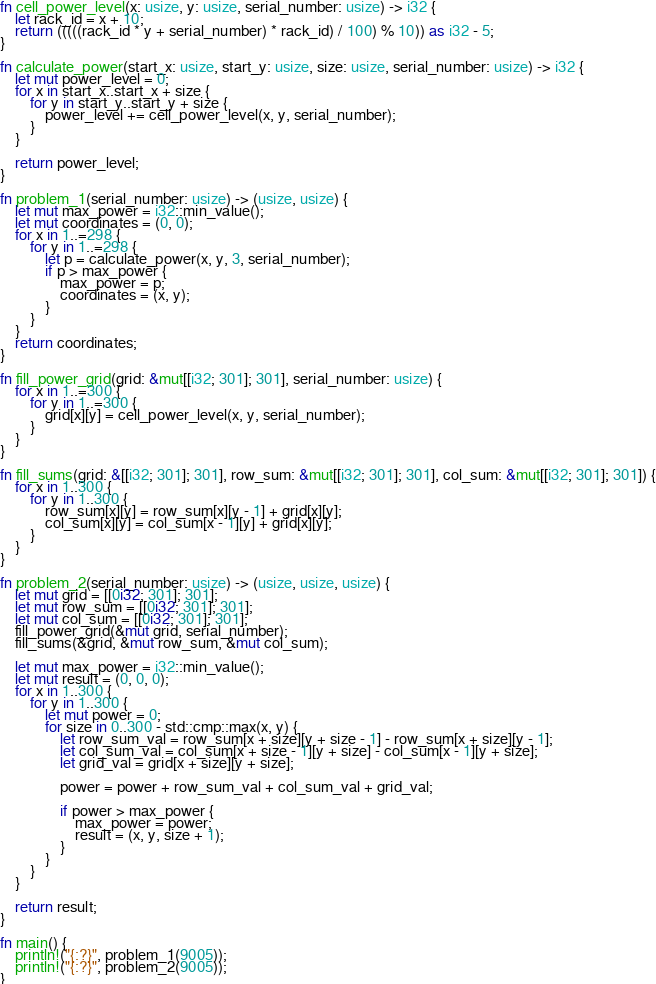<code> <loc_0><loc_0><loc_500><loc_500><_Rust_>fn cell_power_level(x: usize, y: usize, serial_number: usize) -> i32 {
    let rack_id = x + 10;
    return (((((rack_id * y + serial_number) * rack_id) / 100) % 10)) as i32 - 5;
}

fn calculate_power(start_x: usize, start_y: usize, size: usize, serial_number: usize) -> i32 {
    let mut power_level = 0;
    for x in start_x..start_x + size {
        for y in start_y..start_y + size {
            power_level += cell_power_level(x, y, serial_number);
        }
    }

    return power_level;
}

fn problem_1(serial_number: usize) -> (usize, usize) {
    let mut max_power = i32::min_value();
    let mut coordinates = (0, 0);
    for x in 1..=298 {
        for y in 1..=298 {
            let p = calculate_power(x, y, 3, serial_number);
            if p > max_power {
                max_power = p;
                coordinates = (x, y);
            }
        }
    }
    return coordinates;
}

fn fill_power_grid(grid: &mut[[i32; 301]; 301], serial_number: usize) {
    for x in 1..=300 {
        for y in 1..=300 {
            grid[x][y] = cell_power_level(x, y, serial_number);
        }
    }
}

fn fill_sums(grid: &[[i32; 301]; 301], row_sum: &mut[[i32; 301]; 301], col_sum: &mut[[i32; 301]; 301]) {
    for x in 1..300 {
        for y in 1..300 {
            row_sum[x][y] = row_sum[x][y - 1] + grid[x][y];
            col_sum[x][y] = col_sum[x - 1][y] + grid[x][y];
        }
    }
}

fn problem_2(serial_number: usize) -> (usize, usize, usize) {
    let mut grid = [[0i32; 301]; 301];
    let mut row_sum = [[0i32; 301]; 301];
    let mut col_sum = [[0i32; 301]; 301];
    fill_power_grid(&mut grid, serial_number);
    fill_sums(&grid, &mut row_sum, &mut col_sum);

    let mut max_power = i32::min_value();
    let mut result = (0, 0, 0);
    for x in 1..300 {
        for y in 1..300 {
            let mut power = 0;
            for size in 0..300 - std::cmp::max(x, y) {
                let row_sum_val = row_sum[x + size][y + size - 1] - row_sum[x + size][y - 1];
                let col_sum_val = col_sum[x + size - 1][y + size] - col_sum[x - 1][y + size];
                let grid_val = grid[x + size][y + size];

                power = power + row_sum_val + col_sum_val + grid_val;

                if power > max_power {
                    max_power = power;
                    result = (x, y, size + 1);
                }
            }
        }
    }

    return result;
}

fn main() {
    println!("{:?}", problem_1(9005));
    println!("{:?}", problem_2(9005));
}
</code> 